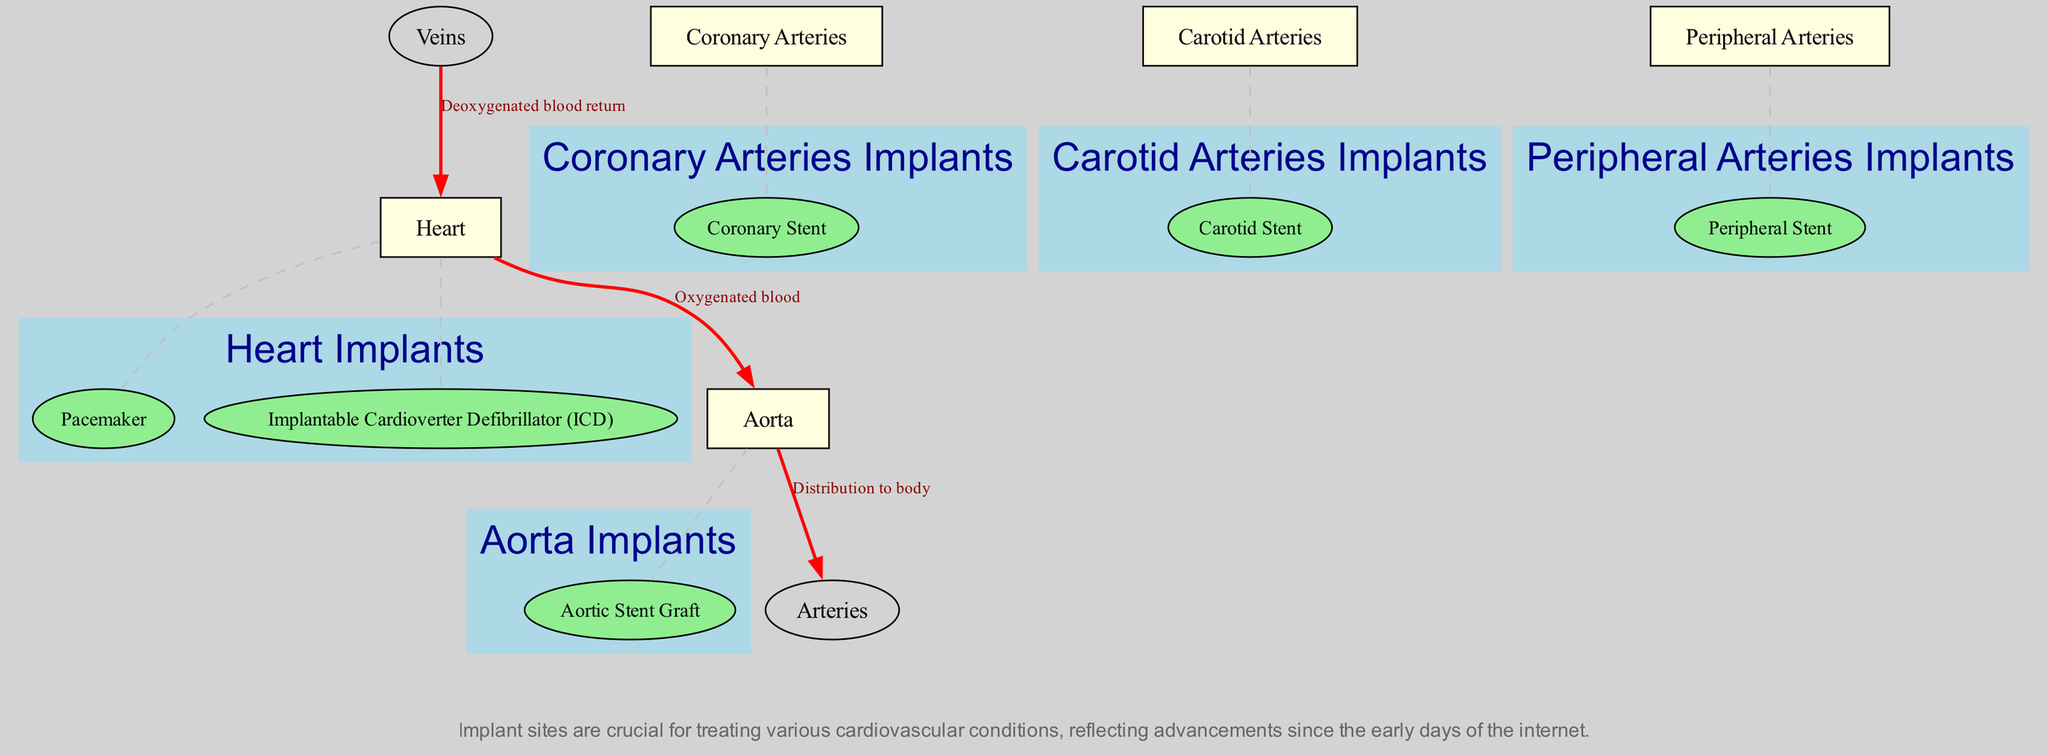What structures are highlighted for cardiovascular implants? The diagram lists major components of the human circulatory system where implants can be placed: Heart, Aorta, Coronary Arteries, Carotid Arteries, and Peripheral Arteries.
Answer: Heart, Aorta, Coronary Arteries, Carotid Arteries, Peripheral Arteries How many implant types are shown for the Heart? In the diagram, the Heart is associated with two implant types: Pacemaker and Implantable Cardioverter Defibrillator (ICD). Counting these gives a total of two.
Answer: 2 What is the direction of oxygenated blood flow starting from the Heart? The flow begins at the Heart and moves to the Aorta, indicating the first segment of oxygenated blood circulation.
Answer: Aorta Which implant is associated with the Aorta? According to the diagram, the implant associated with the Aorta is specifically the Aortic Stent Graft. This can be directly linked to the Aorta node in the diagram.
Answer: Aortic Stent Graft What is the relationship between the Veins and the Heart? The relationship is represented through a flow of deoxygenated blood, indicating that the veins carry blood back to the Heart, completing the circulation process highlighted in the diagram.
Answer: Deoxygenated blood return How many total main components are displayed in the diagram? The diagram features five main components: Heart, Aorta, Coronary Arteries, Carotid Arteries, and Peripheral Arteries. Thus, a simple count leads to five main components overall.
Answer: 5 Which implant is related to the Peripheral Arteries? The Peripheral Arteries have an associated implant called the Peripheral Stent, which is noted in the diagram's definitions of the main components and their respective implants.
Answer: Peripheral Stent What color indicates the blood flow in the diagram? The flow of blood is represented by red arrows, showcasing the different pathways blood travels between the components of the circulatory system.
Answer: Red Name one major function of the Cardiovascular implants highlighted. The implants serve various functions such as treating specific cardiovascular conditions, thereby enhancing heart function and blood flow within the circulatory system as signified by their placement.
Answer: Treating cardiovascular conditions 